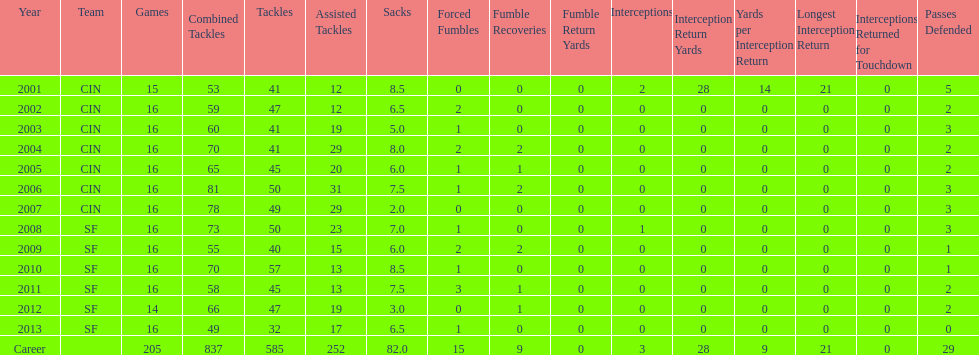How many years did he play where he did not recover a fumble? 7. 